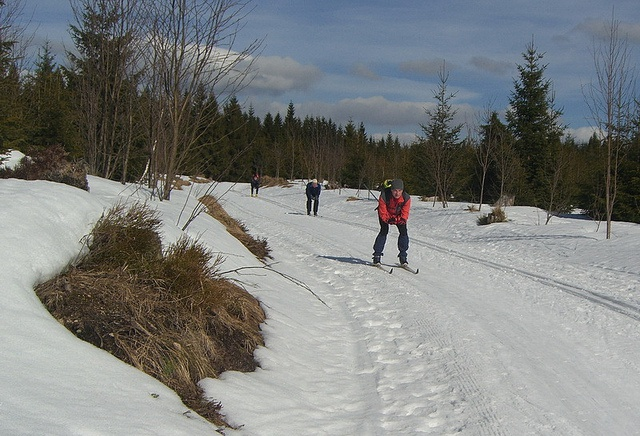Describe the objects in this image and their specific colors. I can see people in black, maroon, and gray tones, people in black, gray, and darkgray tones, people in black, gray, darkgray, and darkgreen tones, skis in black, gray, and darkgray tones, and backpack in black, darkgreen, olive, and gray tones in this image. 